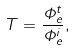<formula> <loc_0><loc_0><loc_500><loc_500>T = { \frac { \Phi _ { e } ^ { t } } { \Phi _ { e } ^ { i } } } ,</formula> 